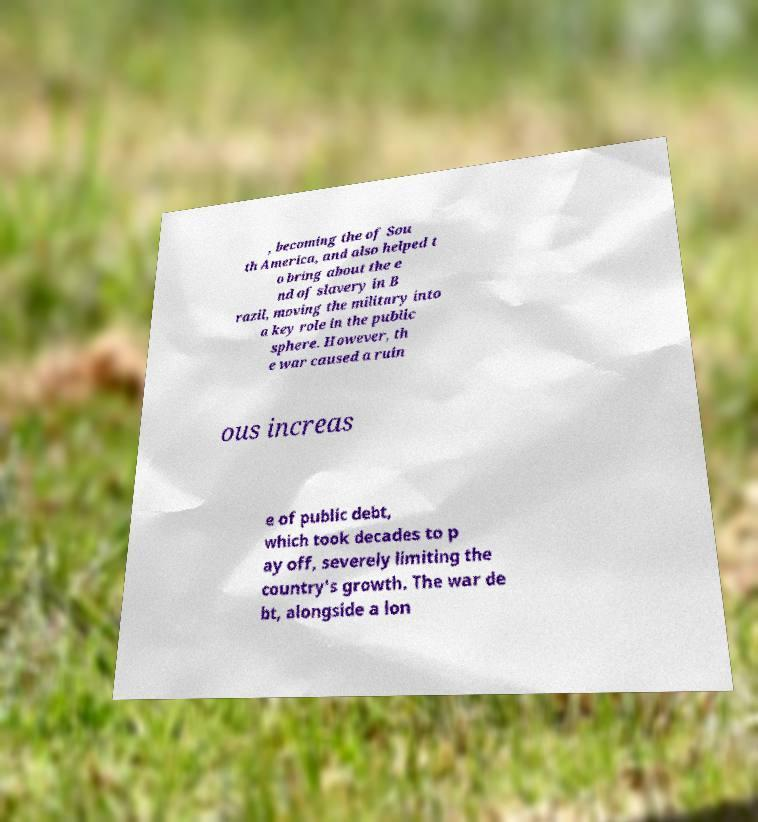Can you accurately transcribe the text from the provided image for me? , becoming the of Sou th America, and also helped t o bring about the e nd of slavery in B razil, moving the military into a key role in the public sphere. However, th e war caused a ruin ous increas e of public debt, which took decades to p ay off, severely limiting the country's growth. The war de bt, alongside a lon 